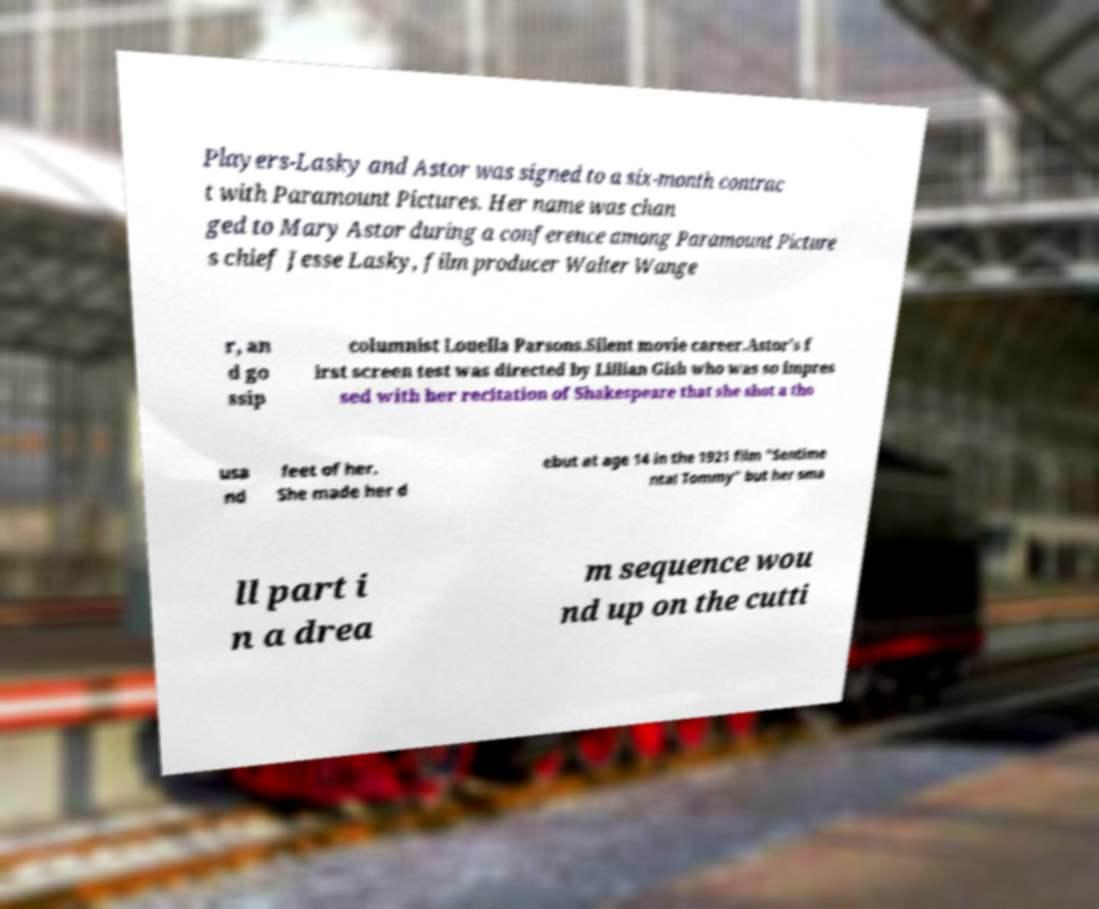Could you assist in decoding the text presented in this image and type it out clearly? Players-Lasky and Astor was signed to a six-month contrac t with Paramount Pictures. Her name was chan ged to Mary Astor during a conference among Paramount Picture s chief Jesse Lasky, film producer Walter Wange r, an d go ssip columnist Louella Parsons.Silent movie career.Astor's f irst screen test was directed by Lillian Gish who was so impres sed with her recitation of Shakespeare that she shot a tho usa nd feet of her. She made her d ebut at age 14 in the 1921 film "Sentime ntal Tommy" but her sma ll part i n a drea m sequence wou nd up on the cutti 